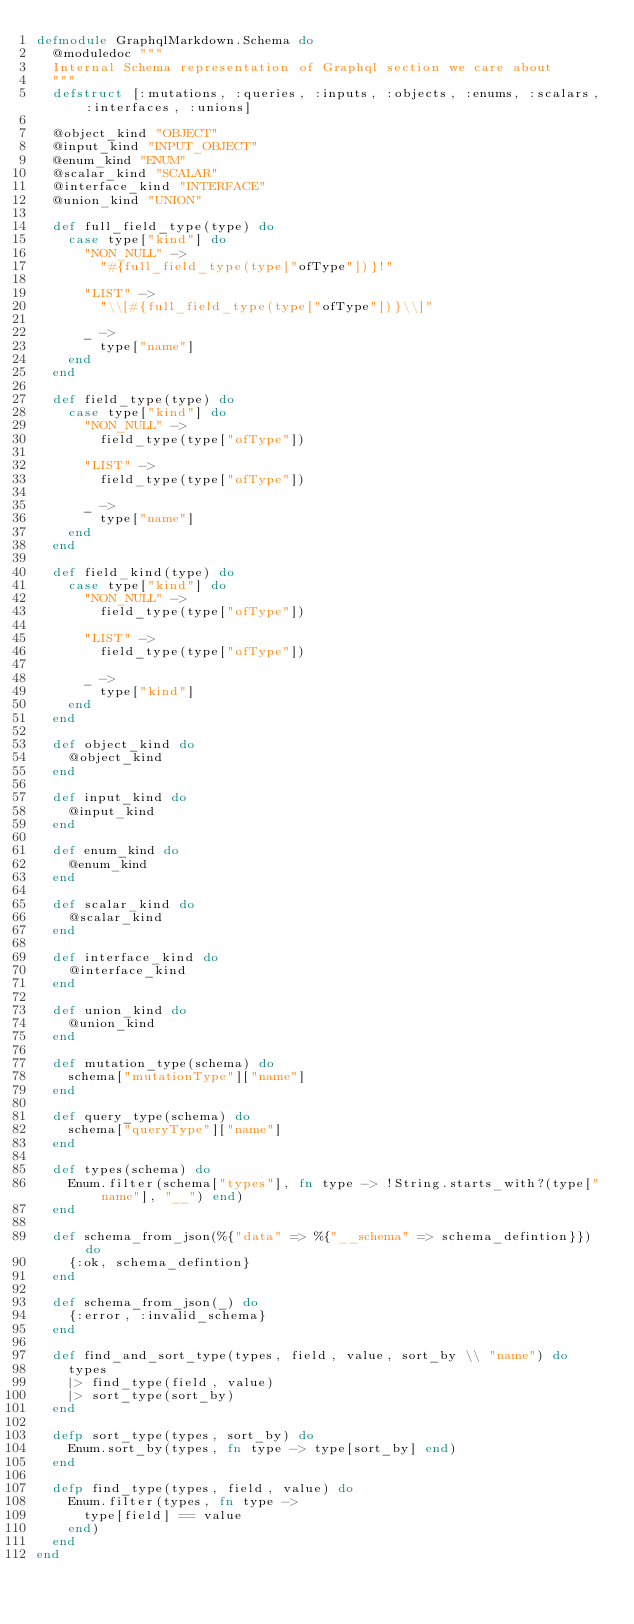Convert code to text. <code><loc_0><loc_0><loc_500><loc_500><_Elixir_>defmodule GraphqlMarkdown.Schema do
  @moduledoc """
  Internal Schema representation of Graphql section we care about
  """
  defstruct [:mutations, :queries, :inputs, :objects, :enums, :scalars, :interfaces, :unions]

  @object_kind "OBJECT"
  @input_kind "INPUT_OBJECT"
  @enum_kind "ENUM"
  @scalar_kind "SCALAR"
  @interface_kind "INTERFACE"
  @union_kind "UNION"

  def full_field_type(type) do
    case type["kind"] do
      "NON_NULL" ->
        "#{full_field_type(type["ofType"])}!"

      "LIST" ->
        "\\[#{full_field_type(type["ofType"])}\\]"

      _ ->
        type["name"]
    end
  end

  def field_type(type) do
    case type["kind"] do
      "NON_NULL" ->
        field_type(type["ofType"])

      "LIST" ->
        field_type(type["ofType"])

      _ ->
        type["name"]
    end
  end

  def field_kind(type) do
    case type["kind"] do
      "NON_NULL" ->
        field_type(type["ofType"])

      "LIST" ->
        field_type(type["ofType"])

      _ ->
        type["kind"]
    end
  end

  def object_kind do
    @object_kind
  end

  def input_kind do
    @input_kind
  end

  def enum_kind do
    @enum_kind
  end

  def scalar_kind do
    @scalar_kind
  end

  def interface_kind do
    @interface_kind
  end

  def union_kind do
    @union_kind
  end

  def mutation_type(schema) do
    schema["mutationType"]["name"]
  end

  def query_type(schema) do
    schema["queryType"]["name"]
  end

  def types(schema) do
    Enum.filter(schema["types"], fn type -> !String.starts_with?(type["name"], "__") end)
  end

  def schema_from_json(%{"data" => %{"__schema" => schema_defintion}}) do
    {:ok, schema_defintion}
  end

  def schema_from_json(_) do
    {:error, :invalid_schema}
  end

  def find_and_sort_type(types, field, value, sort_by \\ "name") do
    types
    |> find_type(field, value)
    |> sort_type(sort_by)
  end

  defp sort_type(types, sort_by) do
    Enum.sort_by(types, fn type -> type[sort_by] end)
  end

  defp find_type(types, field, value) do
    Enum.filter(types, fn type ->
      type[field] == value
    end)
  end
end
</code> 